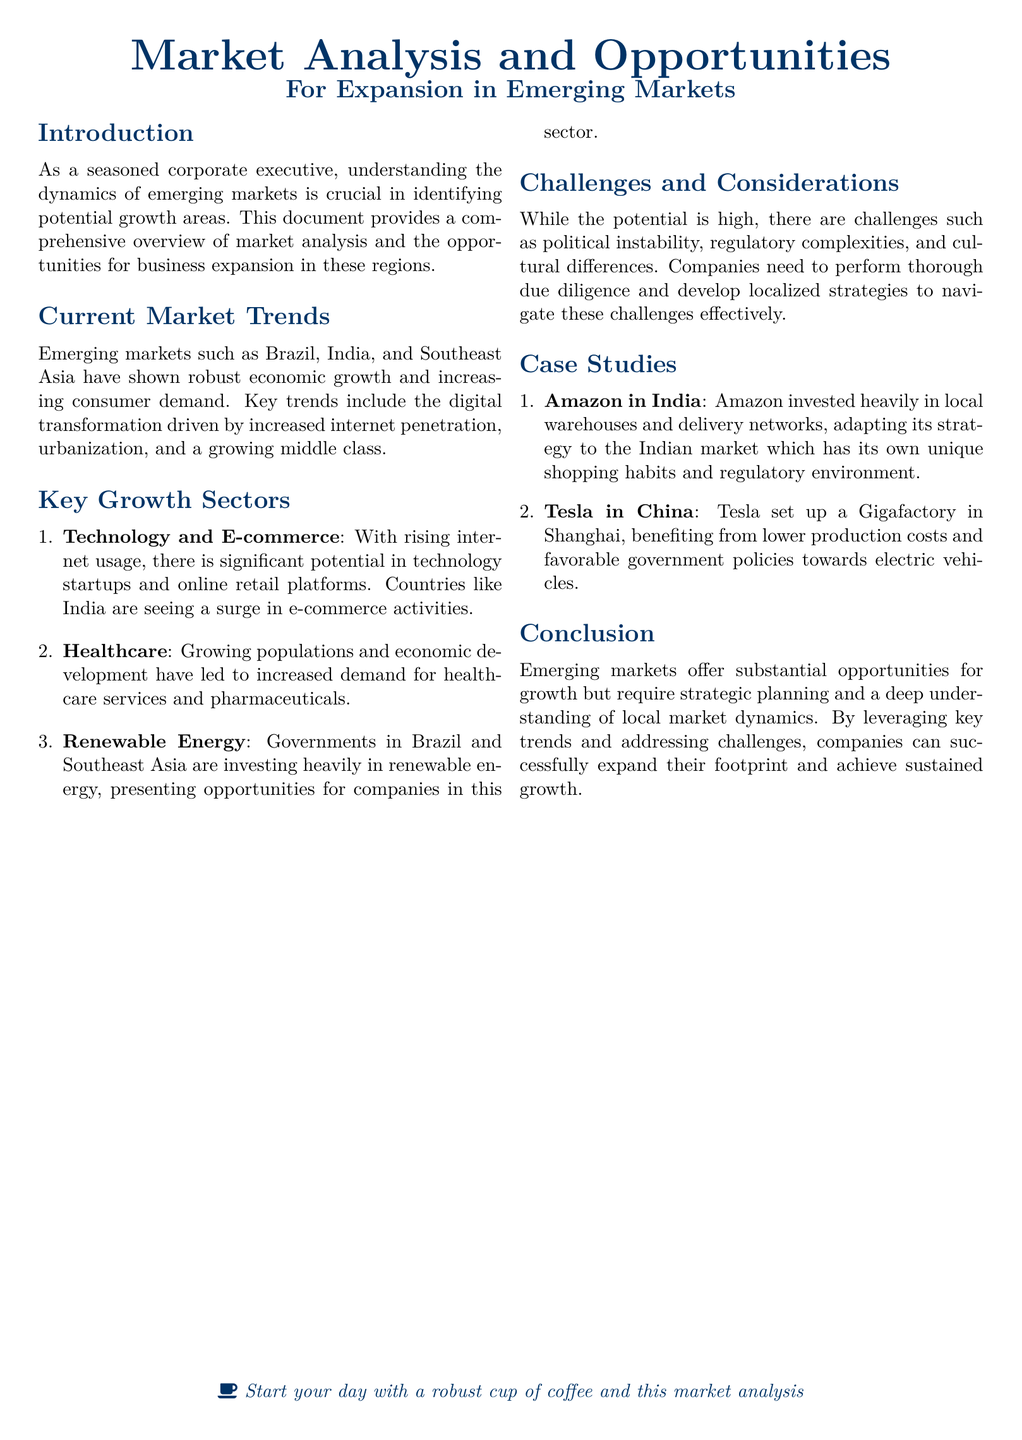What are the key growth sectors mentioned? The document lists three key growth sectors: Technology and E-commerce, Healthcare, and Renewable Energy.
Answer: Technology and E-commerce, Healthcare, Renewable Energy Which country is highlighted for its e-commerce activities? The document emphasizes India as a country experiencing a surge in e-commerce activities.
Answer: India What challenge must companies navigate when entering emerging markets? Companies face several challenges, but one significant one is political instability, as stated in the document.
Answer: Political instability How does Amazon adapt its strategy in India? Amazon invested heavily in local warehouses and delivery networks to cater to India's unique market conditions.
Answer: Local warehouses and delivery networks What is a notable investment made by Tesla in China? Tesla set up a Gigafactory in Shanghai, as mentioned in the case studies of the document.
Answer: Gigafactory in Shanghai What promotes growing populations and economic development in emerging markets? The document refers to the increasing consumer demand and urbanization as promoters of population growth and economic development.
Answer: Urbanization What is essential for companies to perform according to the challenges section? Companies need to perform thorough due diligence as they navigate challenges in emerging markets.
Answer: Thorough due diligence Name one specific emerging market highlighted in the document. The document highlights Brazil as one of the emerging markets showing robust economic growth.
Answer: Brazil What drives the digital transformation in emerging markets? Increased internet penetration is cited as a driver of digital transformation in emerging markets.
Answer: Increased internet penetration 